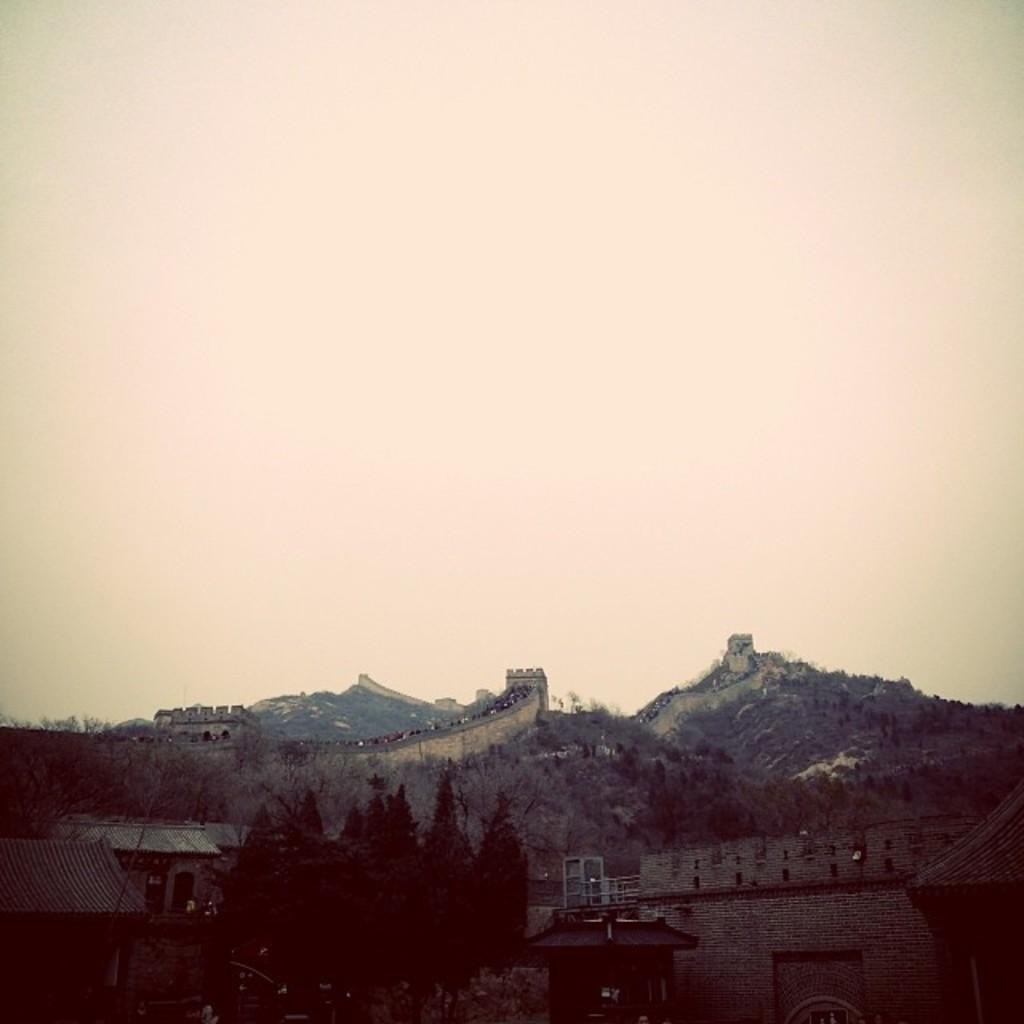What type of structures can be seen in the image? There are sheds in the image. What other natural elements are present in the image? There are trees in the image. Can you describe any objects visible in the image? There are objects in the image. What can be seen in the distance in the background of the image? There are mountains visible in the background of the image. What else is visible in the background of the image? The sky is visible in the background of the image. What type of floor can be seen in the image? There is no floor visible in the image; it is an outdoor scene with sheds, trees, objects, mountains, and the sky. 